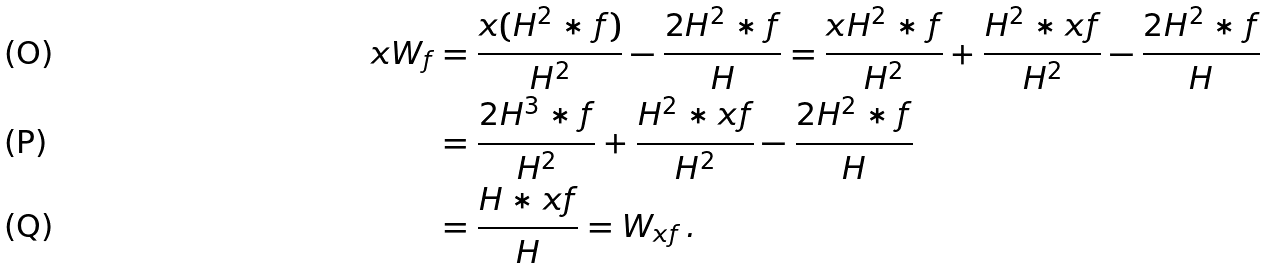Convert formula to latex. <formula><loc_0><loc_0><loc_500><loc_500>x W _ { f } & = \frac { x ( H ^ { 2 } \ast f ) } { H ^ { 2 } } - \frac { 2 H ^ { 2 } \ast f } { H } = \frac { x H ^ { 2 } \ast f } { H ^ { 2 } } + \frac { H ^ { 2 } \ast x f } { H ^ { 2 } } - \frac { 2 H ^ { 2 } \ast f } { H } \\ & = \frac { 2 H ^ { 3 } \ast f } { H ^ { 2 } } + \frac { H ^ { 2 } \ast x f } { H ^ { 2 } } - \frac { 2 H ^ { 2 } \ast f } { H } \\ & = \frac { H \ast x f } { H } = W _ { x f } \, .</formula> 